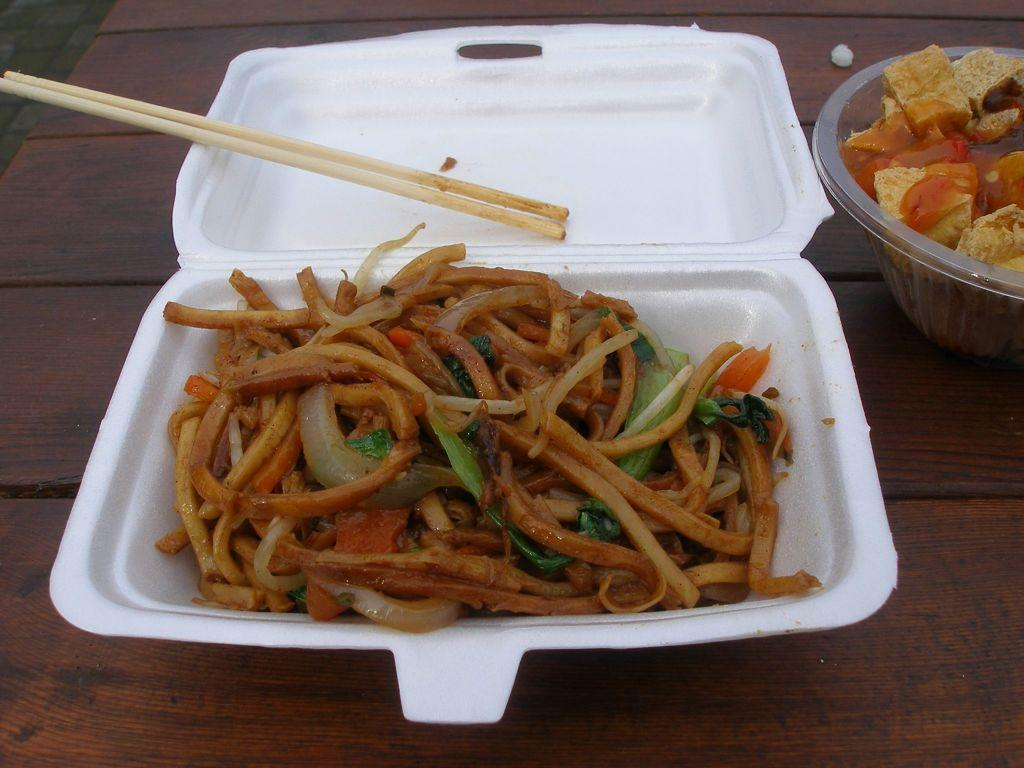What type of furniture is in the image? There is a table in the image. What is placed on the table? There is a white box containing noodles and a bowl containing food on the table. What utensils are present on the table? Chopsticks are present on the table. How many trees can be seen growing out of the white box in the image? There are no trees present in the image, especially not growing out of the white box. 